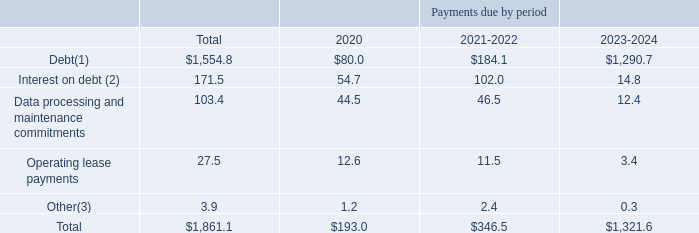As of December 31, 2019, our required annual payments relating to these contractual obligations were as follows (in millions):
(1) Includes finance lease obligations.
(2) These calculations include the effect of our interest rate swaps and assume that (a) applicable margins remain constant; (b) our term A loan and revolving credit facility variable rate debt is priced at the one-month LIBOR rate in effect as of December 31, 2019; (c) only mandatory debt repayments are made; and (d) no refinancing occurs at debt maturity.
(3) Other includes commitment fees on our revolving credit facility and rating agencies fees.
What did the calculation for Debt include? Finance lease obligations. What did the calculation for Other include? Commitment fees on our revolving credit facility and rating agencies fees. What was the total debt?
Answer scale should be: million. 1,554.8. What was the difference between Total Debt and Total Interest on Debt?
Answer scale should be: million. 1,554.8-171.5
Answer: 1383.3. For the period 2021-2022, how many contractual obligations exceeded $100 million? Debt##Interest on debt
Answer: 2. What was the percentage change in the total contractual obligations between the periods of 2020 and 2021-2022?
Answer scale should be: percent. (346.5-193.0)/193.0
Answer: 79.53. 